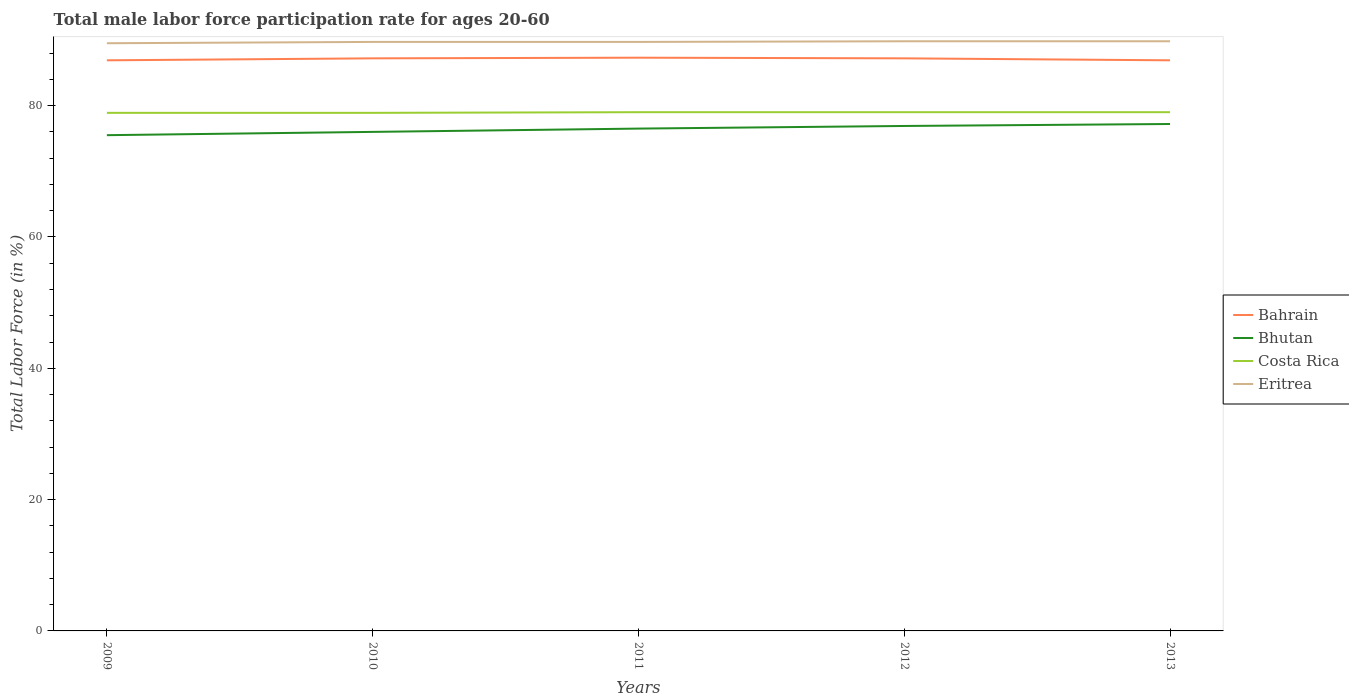Is the number of lines equal to the number of legend labels?
Your answer should be compact. Yes. Across all years, what is the maximum male labor force participation rate in Costa Rica?
Offer a very short reply. 78.9. In which year was the male labor force participation rate in Bhutan maximum?
Offer a very short reply. 2009. What is the difference between the highest and the second highest male labor force participation rate in Costa Rica?
Keep it short and to the point. 0.1. Is the male labor force participation rate in Costa Rica strictly greater than the male labor force participation rate in Eritrea over the years?
Keep it short and to the point. Yes. How many years are there in the graph?
Your answer should be very brief. 5. What is the difference between two consecutive major ticks on the Y-axis?
Your answer should be very brief. 20. Are the values on the major ticks of Y-axis written in scientific E-notation?
Provide a succinct answer. No. Does the graph contain any zero values?
Make the answer very short. No. How are the legend labels stacked?
Your answer should be very brief. Vertical. What is the title of the graph?
Your response must be concise. Total male labor force participation rate for ages 20-60. What is the label or title of the X-axis?
Provide a succinct answer. Years. What is the label or title of the Y-axis?
Offer a terse response. Total Labor Force (in %). What is the Total Labor Force (in %) in Bahrain in 2009?
Make the answer very short. 86.9. What is the Total Labor Force (in %) of Bhutan in 2009?
Provide a short and direct response. 75.5. What is the Total Labor Force (in %) of Costa Rica in 2009?
Keep it short and to the point. 78.9. What is the Total Labor Force (in %) in Eritrea in 2009?
Offer a very short reply. 89.5. What is the Total Labor Force (in %) in Bahrain in 2010?
Your answer should be compact. 87.2. What is the Total Labor Force (in %) in Costa Rica in 2010?
Give a very brief answer. 78.9. What is the Total Labor Force (in %) of Eritrea in 2010?
Your answer should be very brief. 89.7. What is the Total Labor Force (in %) of Bahrain in 2011?
Make the answer very short. 87.3. What is the Total Labor Force (in %) of Bhutan in 2011?
Your response must be concise. 76.5. What is the Total Labor Force (in %) in Costa Rica in 2011?
Keep it short and to the point. 79. What is the Total Labor Force (in %) of Eritrea in 2011?
Give a very brief answer. 89.7. What is the Total Labor Force (in %) in Bahrain in 2012?
Offer a very short reply. 87.2. What is the Total Labor Force (in %) in Bhutan in 2012?
Your response must be concise. 76.9. What is the Total Labor Force (in %) of Costa Rica in 2012?
Your response must be concise. 79. What is the Total Labor Force (in %) in Eritrea in 2012?
Give a very brief answer. 89.8. What is the Total Labor Force (in %) of Bahrain in 2013?
Offer a very short reply. 86.9. What is the Total Labor Force (in %) in Bhutan in 2013?
Offer a terse response. 77.2. What is the Total Labor Force (in %) in Costa Rica in 2013?
Offer a terse response. 79. What is the Total Labor Force (in %) in Eritrea in 2013?
Provide a succinct answer. 89.8. Across all years, what is the maximum Total Labor Force (in %) of Bahrain?
Your answer should be compact. 87.3. Across all years, what is the maximum Total Labor Force (in %) in Bhutan?
Give a very brief answer. 77.2. Across all years, what is the maximum Total Labor Force (in %) in Costa Rica?
Give a very brief answer. 79. Across all years, what is the maximum Total Labor Force (in %) of Eritrea?
Your answer should be compact. 89.8. Across all years, what is the minimum Total Labor Force (in %) of Bahrain?
Provide a short and direct response. 86.9. Across all years, what is the minimum Total Labor Force (in %) in Bhutan?
Your response must be concise. 75.5. Across all years, what is the minimum Total Labor Force (in %) in Costa Rica?
Give a very brief answer. 78.9. Across all years, what is the minimum Total Labor Force (in %) of Eritrea?
Offer a very short reply. 89.5. What is the total Total Labor Force (in %) of Bahrain in the graph?
Give a very brief answer. 435.5. What is the total Total Labor Force (in %) of Bhutan in the graph?
Keep it short and to the point. 382.1. What is the total Total Labor Force (in %) of Costa Rica in the graph?
Ensure brevity in your answer.  394.8. What is the total Total Labor Force (in %) in Eritrea in the graph?
Your response must be concise. 448.5. What is the difference between the Total Labor Force (in %) of Costa Rica in 2009 and that in 2010?
Provide a short and direct response. 0. What is the difference between the Total Labor Force (in %) in Bahrain in 2009 and that in 2011?
Your answer should be compact. -0.4. What is the difference between the Total Labor Force (in %) of Bhutan in 2009 and that in 2011?
Offer a very short reply. -1. What is the difference between the Total Labor Force (in %) in Eritrea in 2009 and that in 2011?
Provide a short and direct response. -0.2. What is the difference between the Total Labor Force (in %) of Eritrea in 2009 and that in 2012?
Offer a very short reply. -0.3. What is the difference between the Total Labor Force (in %) of Eritrea in 2009 and that in 2013?
Ensure brevity in your answer.  -0.3. What is the difference between the Total Labor Force (in %) of Bhutan in 2010 and that in 2011?
Offer a terse response. -0.5. What is the difference between the Total Labor Force (in %) of Eritrea in 2010 and that in 2011?
Your answer should be compact. 0. What is the difference between the Total Labor Force (in %) in Bahrain in 2010 and that in 2012?
Make the answer very short. 0. What is the difference between the Total Labor Force (in %) of Bhutan in 2010 and that in 2012?
Make the answer very short. -0.9. What is the difference between the Total Labor Force (in %) of Eritrea in 2010 and that in 2012?
Provide a short and direct response. -0.1. What is the difference between the Total Labor Force (in %) in Bahrain in 2010 and that in 2013?
Your answer should be compact. 0.3. What is the difference between the Total Labor Force (in %) in Bhutan in 2011 and that in 2012?
Ensure brevity in your answer.  -0.4. What is the difference between the Total Labor Force (in %) of Costa Rica in 2011 and that in 2012?
Make the answer very short. 0. What is the difference between the Total Labor Force (in %) of Bahrain in 2011 and that in 2013?
Your answer should be compact. 0.4. What is the difference between the Total Labor Force (in %) in Bhutan in 2011 and that in 2013?
Give a very brief answer. -0.7. What is the difference between the Total Labor Force (in %) in Bhutan in 2012 and that in 2013?
Ensure brevity in your answer.  -0.3. What is the difference between the Total Labor Force (in %) in Costa Rica in 2012 and that in 2013?
Keep it short and to the point. 0. What is the difference between the Total Labor Force (in %) of Bahrain in 2009 and the Total Labor Force (in %) of Bhutan in 2010?
Ensure brevity in your answer.  10.9. What is the difference between the Total Labor Force (in %) of Bahrain in 2009 and the Total Labor Force (in %) of Costa Rica in 2010?
Give a very brief answer. 8. What is the difference between the Total Labor Force (in %) of Bhutan in 2009 and the Total Labor Force (in %) of Eritrea in 2010?
Make the answer very short. -14.2. What is the difference between the Total Labor Force (in %) of Costa Rica in 2009 and the Total Labor Force (in %) of Eritrea in 2010?
Make the answer very short. -10.8. What is the difference between the Total Labor Force (in %) in Bahrain in 2009 and the Total Labor Force (in %) in Bhutan in 2011?
Offer a very short reply. 10.4. What is the difference between the Total Labor Force (in %) of Bahrain in 2009 and the Total Labor Force (in %) of Costa Rica in 2011?
Your answer should be very brief. 7.9. What is the difference between the Total Labor Force (in %) of Bahrain in 2009 and the Total Labor Force (in %) of Eritrea in 2011?
Ensure brevity in your answer.  -2.8. What is the difference between the Total Labor Force (in %) of Bahrain in 2009 and the Total Labor Force (in %) of Bhutan in 2012?
Keep it short and to the point. 10. What is the difference between the Total Labor Force (in %) in Bahrain in 2009 and the Total Labor Force (in %) in Costa Rica in 2012?
Your answer should be very brief. 7.9. What is the difference between the Total Labor Force (in %) in Bahrain in 2009 and the Total Labor Force (in %) in Eritrea in 2012?
Keep it short and to the point. -2.9. What is the difference between the Total Labor Force (in %) in Bhutan in 2009 and the Total Labor Force (in %) in Costa Rica in 2012?
Offer a terse response. -3.5. What is the difference between the Total Labor Force (in %) of Bhutan in 2009 and the Total Labor Force (in %) of Eritrea in 2012?
Provide a succinct answer. -14.3. What is the difference between the Total Labor Force (in %) in Bahrain in 2009 and the Total Labor Force (in %) in Bhutan in 2013?
Your answer should be very brief. 9.7. What is the difference between the Total Labor Force (in %) of Bahrain in 2009 and the Total Labor Force (in %) of Costa Rica in 2013?
Provide a short and direct response. 7.9. What is the difference between the Total Labor Force (in %) of Bahrain in 2009 and the Total Labor Force (in %) of Eritrea in 2013?
Your answer should be very brief. -2.9. What is the difference between the Total Labor Force (in %) of Bhutan in 2009 and the Total Labor Force (in %) of Eritrea in 2013?
Provide a short and direct response. -14.3. What is the difference between the Total Labor Force (in %) of Bhutan in 2010 and the Total Labor Force (in %) of Costa Rica in 2011?
Your answer should be compact. -3. What is the difference between the Total Labor Force (in %) in Bhutan in 2010 and the Total Labor Force (in %) in Eritrea in 2011?
Your answer should be compact. -13.7. What is the difference between the Total Labor Force (in %) in Bahrain in 2010 and the Total Labor Force (in %) in Costa Rica in 2013?
Your answer should be compact. 8.2. What is the difference between the Total Labor Force (in %) of Bahrain in 2010 and the Total Labor Force (in %) of Eritrea in 2013?
Give a very brief answer. -2.6. What is the difference between the Total Labor Force (in %) of Bhutan in 2010 and the Total Labor Force (in %) of Costa Rica in 2013?
Your answer should be very brief. -3. What is the difference between the Total Labor Force (in %) of Bahrain in 2011 and the Total Labor Force (in %) of Eritrea in 2012?
Keep it short and to the point. -2.5. What is the difference between the Total Labor Force (in %) in Bhutan in 2011 and the Total Labor Force (in %) in Eritrea in 2012?
Provide a short and direct response. -13.3. What is the difference between the Total Labor Force (in %) of Costa Rica in 2011 and the Total Labor Force (in %) of Eritrea in 2012?
Provide a short and direct response. -10.8. What is the difference between the Total Labor Force (in %) of Bahrain in 2011 and the Total Labor Force (in %) of Eritrea in 2013?
Your answer should be very brief. -2.5. What is the difference between the Total Labor Force (in %) of Bhutan in 2011 and the Total Labor Force (in %) of Eritrea in 2013?
Your answer should be very brief. -13.3. What is the difference between the Total Labor Force (in %) of Bahrain in 2012 and the Total Labor Force (in %) of Costa Rica in 2013?
Keep it short and to the point. 8.2. What is the difference between the Total Labor Force (in %) in Bahrain in 2012 and the Total Labor Force (in %) in Eritrea in 2013?
Give a very brief answer. -2.6. What is the difference between the Total Labor Force (in %) in Bhutan in 2012 and the Total Labor Force (in %) in Costa Rica in 2013?
Ensure brevity in your answer.  -2.1. What is the difference between the Total Labor Force (in %) in Bhutan in 2012 and the Total Labor Force (in %) in Eritrea in 2013?
Keep it short and to the point. -12.9. What is the average Total Labor Force (in %) of Bahrain per year?
Ensure brevity in your answer.  87.1. What is the average Total Labor Force (in %) of Bhutan per year?
Provide a short and direct response. 76.42. What is the average Total Labor Force (in %) in Costa Rica per year?
Keep it short and to the point. 78.96. What is the average Total Labor Force (in %) in Eritrea per year?
Offer a very short reply. 89.7. In the year 2009, what is the difference between the Total Labor Force (in %) of Bahrain and Total Labor Force (in %) of Bhutan?
Offer a terse response. 11.4. In the year 2009, what is the difference between the Total Labor Force (in %) of Bhutan and Total Labor Force (in %) of Eritrea?
Keep it short and to the point. -14. In the year 2009, what is the difference between the Total Labor Force (in %) of Costa Rica and Total Labor Force (in %) of Eritrea?
Make the answer very short. -10.6. In the year 2010, what is the difference between the Total Labor Force (in %) of Bahrain and Total Labor Force (in %) of Bhutan?
Provide a short and direct response. 11.2. In the year 2010, what is the difference between the Total Labor Force (in %) of Bahrain and Total Labor Force (in %) of Costa Rica?
Offer a terse response. 8.3. In the year 2010, what is the difference between the Total Labor Force (in %) in Bhutan and Total Labor Force (in %) in Eritrea?
Make the answer very short. -13.7. In the year 2010, what is the difference between the Total Labor Force (in %) in Costa Rica and Total Labor Force (in %) in Eritrea?
Give a very brief answer. -10.8. In the year 2011, what is the difference between the Total Labor Force (in %) of Bhutan and Total Labor Force (in %) of Costa Rica?
Make the answer very short. -2.5. In the year 2012, what is the difference between the Total Labor Force (in %) of Bahrain and Total Labor Force (in %) of Costa Rica?
Ensure brevity in your answer.  8.2. In the year 2013, what is the difference between the Total Labor Force (in %) in Bahrain and Total Labor Force (in %) in Costa Rica?
Your answer should be compact. 7.9. In the year 2013, what is the difference between the Total Labor Force (in %) of Costa Rica and Total Labor Force (in %) of Eritrea?
Provide a short and direct response. -10.8. What is the ratio of the Total Labor Force (in %) of Bhutan in 2009 to that in 2011?
Your answer should be very brief. 0.99. What is the ratio of the Total Labor Force (in %) of Bhutan in 2009 to that in 2012?
Your answer should be very brief. 0.98. What is the ratio of the Total Labor Force (in %) in Costa Rica in 2009 to that in 2012?
Provide a succinct answer. 1. What is the ratio of the Total Labor Force (in %) of Eritrea in 2009 to that in 2012?
Provide a short and direct response. 1. What is the ratio of the Total Labor Force (in %) in Bahrain in 2009 to that in 2013?
Provide a short and direct response. 1. What is the ratio of the Total Labor Force (in %) of Bhutan in 2009 to that in 2013?
Your answer should be compact. 0.98. What is the ratio of the Total Labor Force (in %) of Costa Rica in 2009 to that in 2013?
Keep it short and to the point. 1. What is the ratio of the Total Labor Force (in %) in Bahrain in 2010 to that in 2012?
Make the answer very short. 1. What is the ratio of the Total Labor Force (in %) in Bhutan in 2010 to that in 2012?
Offer a very short reply. 0.99. What is the ratio of the Total Labor Force (in %) in Bhutan in 2010 to that in 2013?
Make the answer very short. 0.98. What is the ratio of the Total Labor Force (in %) in Costa Rica in 2010 to that in 2013?
Give a very brief answer. 1. What is the ratio of the Total Labor Force (in %) in Eritrea in 2010 to that in 2013?
Offer a terse response. 1. What is the ratio of the Total Labor Force (in %) of Bahrain in 2011 to that in 2012?
Ensure brevity in your answer.  1. What is the ratio of the Total Labor Force (in %) in Costa Rica in 2011 to that in 2012?
Your answer should be compact. 1. What is the ratio of the Total Labor Force (in %) of Bhutan in 2011 to that in 2013?
Make the answer very short. 0.99. What is the ratio of the Total Labor Force (in %) in Eritrea in 2011 to that in 2013?
Your response must be concise. 1. What is the ratio of the Total Labor Force (in %) of Costa Rica in 2012 to that in 2013?
Provide a succinct answer. 1. What is the difference between the highest and the second highest Total Labor Force (in %) of Bhutan?
Offer a terse response. 0.3. What is the difference between the highest and the lowest Total Labor Force (in %) in Bahrain?
Provide a succinct answer. 0.4. What is the difference between the highest and the lowest Total Labor Force (in %) of Bhutan?
Make the answer very short. 1.7. What is the difference between the highest and the lowest Total Labor Force (in %) of Costa Rica?
Make the answer very short. 0.1. What is the difference between the highest and the lowest Total Labor Force (in %) in Eritrea?
Give a very brief answer. 0.3. 